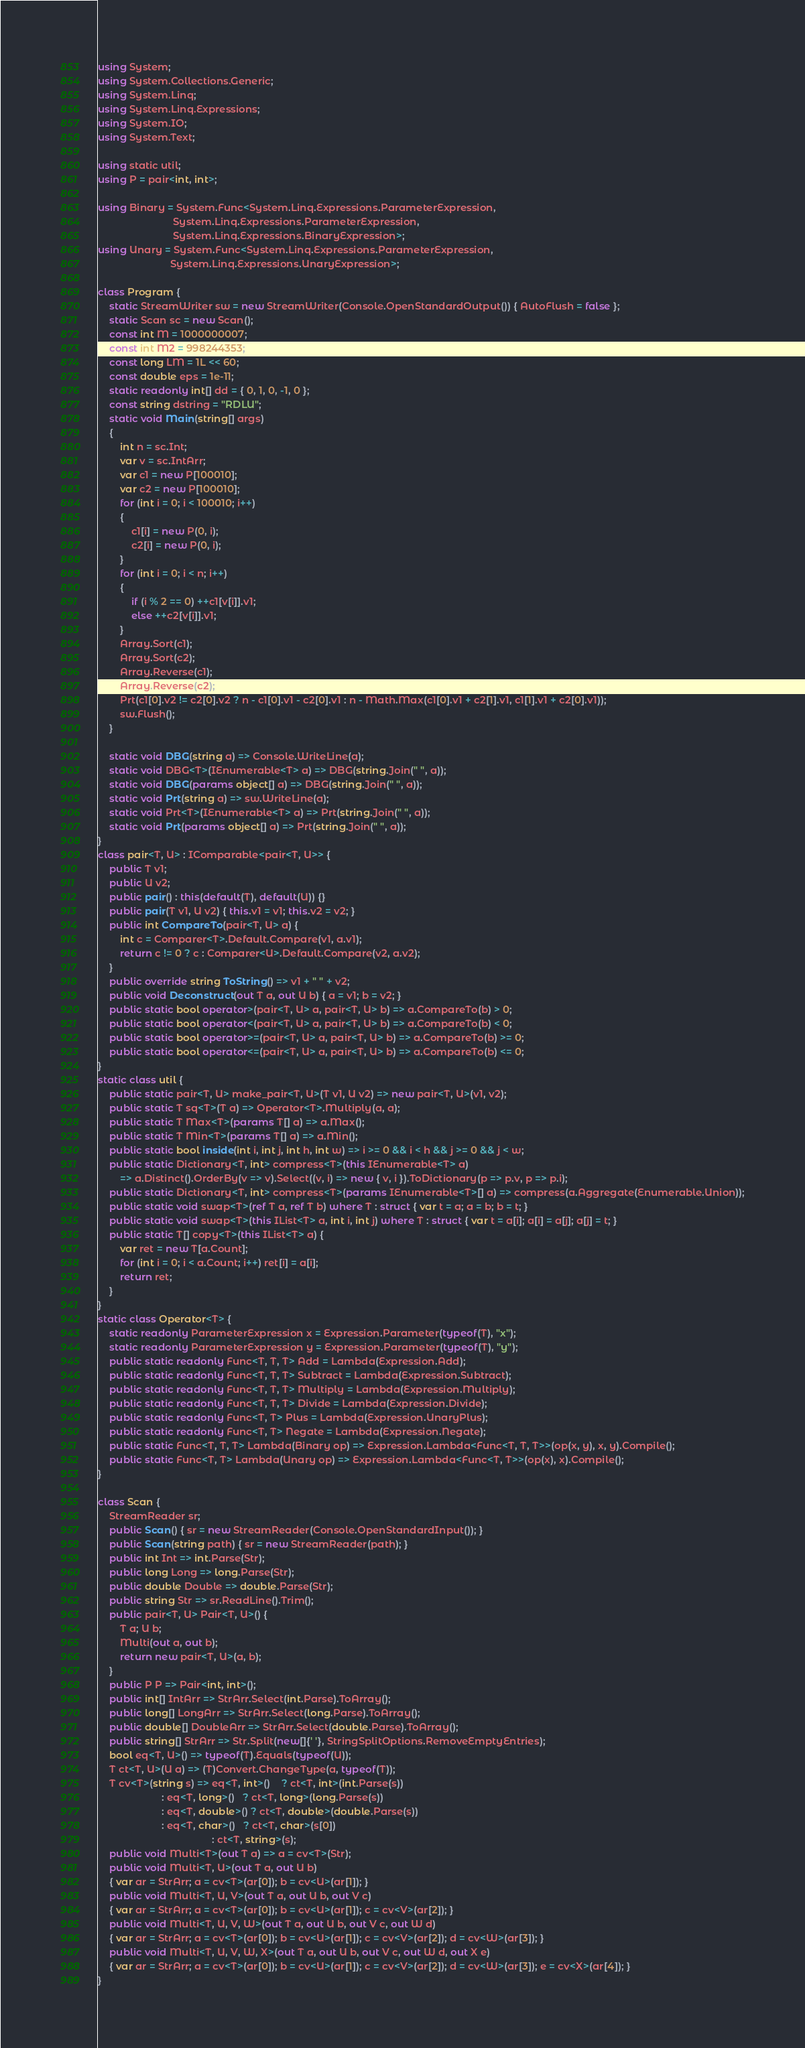Convert code to text. <code><loc_0><loc_0><loc_500><loc_500><_C#_>using System;
using System.Collections.Generic;
using System.Linq;
using System.Linq.Expressions;
using System.IO;
using System.Text;

using static util;
using P = pair<int, int>;

using Binary = System.Func<System.Linq.Expressions.ParameterExpression,
                           System.Linq.Expressions.ParameterExpression,
                           System.Linq.Expressions.BinaryExpression>;
using Unary = System.Func<System.Linq.Expressions.ParameterExpression,
                          System.Linq.Expressions.UnaryExpression>;

class Program {
    static StreamWriter sw = new StreamWriter(Console.OpenStandardOutput()) { AutoFlush = false };
    static Scan sc = new Scan();
    const int M = 1000000007;
    const int M2 = 998244353;
    const long LM = 1L << 60;
    const double eps = 1e-11;
    static readonly int[] dd = { 0, 1, 0, -1, 0 };
    const string dstring = "RDLU";
    static void Main(string[] args)
    {
        int n = sc.Int;
        var v = sc.IntArr;
        var c1 = new P[100010];
        var c2 = new P[100010];
        for (int i = 0; i < 100010; i++)
        {
            c1[i] = new P(0, i);
            c2[i] = new P(0, i);
        }
        for (int i = 0; i < n; i++)
        {
            if (i % 2 == 0) ++c1[v[i]].v1;
            else ++c2[v[i]].v1;
        }
        Array.Sort(c1);
        Array.Sort(c2);
        Array.Reverse(c1);
        Array.Reverse(c2);
        Prt(c1[0].v2 != c2[0].v2 ? n - c1[0].v1 - c2[0].v1 : n - Math.Max(c1[0].v1 + c2[1].v1, c1[1].v1 + c2[0].v1));
        sw.Flush();
    }

    static void DBG(string a) => Console.WriteLine(a);
    static void DBG<T>(IEnumerable<T> a) => DBG(string.Join(" ", a));
    static void DBG(params object[] a) => DBG(string.Join(" ", a));
    static void Prt(string a) => sw.WriteLine(a);
    static void Prt<T>(IEnumerable<T> a) => Prt(string.Join(" ", a));
    static void Prt(params object[] a) => Prt(string.Join(" ", a));
}
class pair<T, U> : IComparable<pair<T, U>> {
    public T v1;
    public U v2;
    public pair() : this(default(T), default(U)) {}
    public pair(T v1, U v2) { this.v1 = v1; this.v2 = v2; }
    public int CompareTo(pair<T, U> a) {
        int c = Comparer<T>.Default.Compare(v1, a.v1);
        return c != 0 ? c : Comparer<U>.Default.Compare(v2, a.v2);
    }
    public override string ToString() => v1 + " " + v2;
    public void Deconstruct(out T a, out U b) { a = v1; b = v2; }
    public static bool operator>(pair<T, U> a, pair<T, U> b) => a.CompareTo(b) > 0;
    public static bool operator<(pair<T, U> a, pair<T, U> b) => a.CompareTo(b) < 0;
    public static bool operator>=(pair<T, U> a, pair<T, U> b) => a.CompareTo(b) >= 0;
    public static bool operator<=(pair<T, U> a, pair<T, U> b) => a.CompareTo(b) <= 0;
}
static class util {
    public static pair<T, U> make_pair<T, U>(T v1, U v2) => new pair<T, U>(v1, v2);
    public static T sq<T>(T a) => Operator<T>.Multiply(a, a);
    public static T Max<T>(params T[] a) => a.Max();
    public static T Min<T>(params T[] a) => a.Min();
    public static bool inside(int i, int j, int h, int w) => i >= 0 && i < h && j >= 0 && j < w;
    public static Dictionary<T, int> compress<T>(this IEnumerable<T> a)
        => a.Distinct().OrderBy(v => v).Select((v, i) => new { v, i }).ToDictionary(p => p.v, p => p.i);
    public static Dictionary<T, int> compress<T>(params IEnumerable<T>[] a) => compress(a.Aggregate(Enumerable.Union));
    public static void swap<T>(ref T a, ref T b) where T : struct { var t = a; a = b; b = t; }
    public static void swap<T>(this IList<T> a, int i, int j) where T : struct { var t = a[i]; a[i] = a[j]; a[j] = t; }
    public static T[] copy<T>(this IList<T> a) {
        var ret = new T[a.Count];
        for (int i = 0; i < a.Count; i++) ret[i] = a[i];
        return ret;
    }
}
static class Operator<T> {
    static readonly ParameterExpression x = Expression.Parameter(typeof(T), "x");
    static readonly ParameterExpression y = Expression.Parameter(typeof(T), "y");
    public static readonly Func<T, T, T> Add = Lambda(Expression.Add);
    public static readonly Func<T, T, T> Subtract = Lambda(Expression.Subtract);
    public static readonly Func<T, T, T> Multiply = Lambda(Expression.Multiply);
    public static readonly Func<T, T, T> Divide = Lambda(Expression.Divide);
    public static readonly Func<T, T> Plus = Lambda(Expression.UnaryPlus);
    public static readonly Func<T, T> Negate = Lambda(Expression.Negate);
    public static Func<T, T, T> Lambda(Binary op) => Expression.Lambda<Func<T, T, T>>(op(x, y), x, y).Compile();
    public static Func<T, T> Lambda(Unary op) => Expression.Lambda<Func<T, T>>(op(x), x).Compile();
}

class Scan {
    StreamReader sr;
    public Scan() { sr = new StreamReader(Console.OpenStandardInput()); }
    public Scan(string path) { sr = new StreamReader(path); }
    public int Int => int.Parse(Str);
    public long Long => long.Parse(Str);
    public double Double => double.Parse(Str);
    public string Str => sr.ReadLine().Trim();
    public pair<T, U> Pair<T, U>() {
        T a; U b;
        Multi(out a, out b);
        return new pair<T, U>(a, b);
    }
    public P P => Pair<int, int>();
    public int[] IntArr => StrArr.Select(int.Parse).ToArray();
    public long[] LongArr => StrArr.Select(long.Parse).ToArray();
    public double[] DoubleArr => StrArr.Select(double.Parse).ToArray();
    public string[] StrArr => Str.Split(new[]{' '}, StringSplitOptions.RemoveEmptyEntries);
    bool eq<T, U>() => typeof(T).Equals(typeof(U));
    T ct<T, U>(U a) => (T)Convert.ChangeType(a, typeof(T));
    T cv<T>(string s) => eq<T, int>()    ? ct<T, int>(int.Parse(s))
                       : eq<T, long>()   ? ct<T, long>(long.Parse(s))
                       : eq<T, double>() ? ct<T, double>(double.Parse(s))
                       : eq<T, char>()   ? ct<T, char>(s[0])
                                         : ct<T, string>(s);
    public void Multi<T>(out T a) => a = cv<T>(Str);
    public void Multi<T, U>(out T a, out U b)
    { var ar = StrArr; a = cv<T>(ar[0]); b = cv<U>(ar[1]); }
    public void Multi<T, U, V>(out T a, out U b, out V c)
    { var ar = StrArr; a = cv<T>(ar[0]); b = cv<U>(ar[1]); c = cv<V>(ar[2]); }
    public void Multi<T, U, V, W>(out T a, out U b, out V c, out W d)
    { var ar = StrArr; a = cv<T>(ar[0]); b = cv<U>(ar[1]); c = cv<V>(ar[2]); d = cv<W>(ar[3]); }
    public void Multi<T, U, V, W, X>(out T a, out U b, out V c, out W d, out X e)
    { var ar = StrArr; a = cv<T>(ar[0]); b = cv<U>(ar[1]); c = cv<V>(ar[2]); d = cv<W>(ar[3]); e = cv<X>(ar[4]); }
}
</code> 